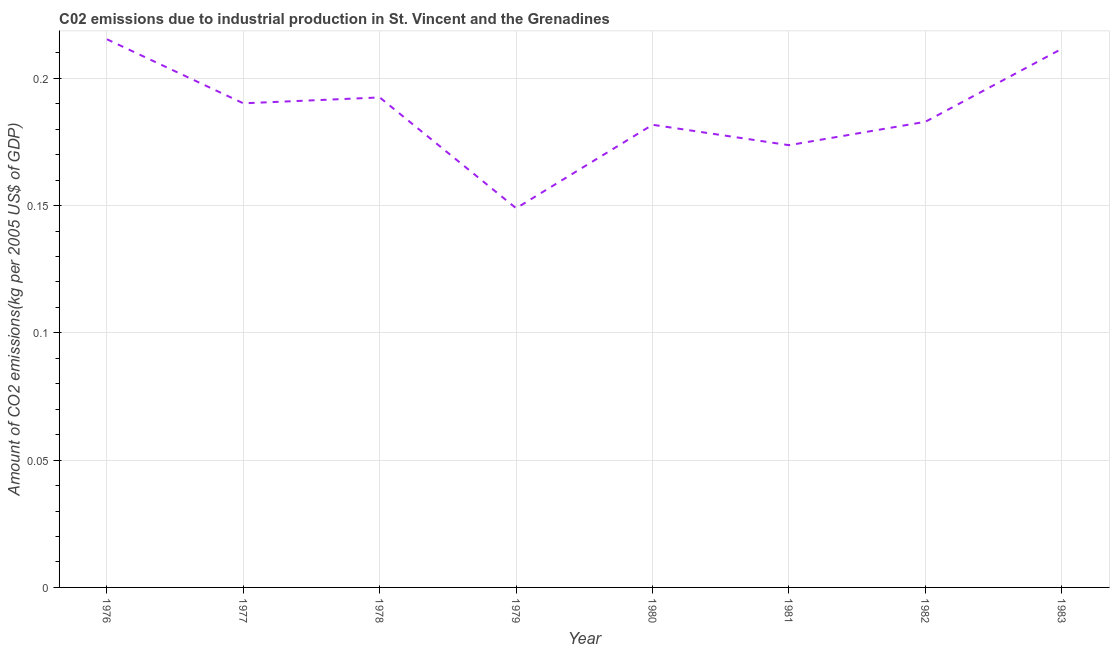What is the amount of co2 emissions in 1977?
Your answer should be compact. 0.19. Across all years, what is the maximum amount of co2 emissions?
Give a very brief answer. 0.22. Across all years, what is the minimum amount of co2 emissions?
Provide a succinct answer. 0.15. In which year was the amount of co2 emissions maximum?
Provide a succinct answer. 1976. In which year was the amount of co2 emissions minimum?
Give a very brief answer. 1979. What is the sum of the amount of co2 emissions?
Offer a terse response. 1.5. What is the difference between the amount of co2 emissions in 1982 and 1983?
Give a very brief answer. -0.03. What is the average amount of co2 emissions per year?
Your answer should be very brief. 0.19. What is the median amount of co2 emissions?
Offer a very short reply. 0.19. Do a majority of the years between 1981 and 1983 (inclusive) have amount of co2 emissions greater than 0.15000000000000002 kg per 2005 US$ of GDP?
Offer a very short reply. Yes. What is the ratio of the amount of co2 emissions in 1980 to that in 1981?
Provide a succinct answer. 1.05. Is the amount of co2 emissions in 1979 less than that in 1983?
Provide a succinct answer. Yes. What is the difference between the highest and the second highest amount of co2 emissions?
Your answer should be very brief. 0. What is the difference between the highest and the lowest amount of co2 emissions?
Ensure brevity in your answer.  0.07. In how many years, is the amount of co2 emissions greater than the average amount of co2 emissions taken over all years?
Provide a succinct answer. 4. Does the amount of co2 emissions monotonically increase over the years?
Your answer should be very brief. No. How many lines are there?
Your response must be concise. 1. How many years are there in the graph?
Give a very brief answer. 8. What is the difference between two consecutive major ticks on the Y-axis?
Your answer should be compact. 0.05. What is the title of the graph?
Give a very brief answer. C02 emissions due to industrial production in St. Vincent and the Grenadines. What is the label or title of the Y-axis?
Provide a succinct answer. Amount of CO2 emissions(kg per 2005 US$ of GDP). What is the Amount of CO2 emissions(kg per 2005 US$ of GDP) in 1976?
Provide a short and direct response. 0.22. What is the Amount of CO2 emissions(kg per 2005 US$ of GDP) of 1977?
Offer a terse response. 0.19. What is the Amount of CO2 emissions(kg per 2005 US$ of GDP) of 1978?
Your answer should be very brief. 0.19. What is the Amount of CO2 emissions(kg per 2005 US$ of GDP) of 1979?
Give a very brief answer. 0.15. What is the Amount of CO2 emissions(kg per 2005 US$ of GDP) in 1980?
Make the answer very short. 0.18. What is the Amount of CO2 emissions(kg per 2005 US$ of GDP) in 1981?
Ensure brevity in your answer.  0.17. What is the Amount of CO2 emissions(kg per 2005 US$ of GDP) in 1982?
Ensure brevity in your answer.  0.18. What is the Amount of CO2 emissions(kg per 2005 US$ of GDP) in 1983?
Provide a succinct answer. 0.21. What is the difference between the Amount of CO2 emissions(kg per 2005 US$ of GDP) in 1976 and 1977?
Your response must be concise. 0.03. What is the difference between the Amount of CO2 emissions(kg per 2005 US$ of GDP) in 1976 and 1978?
Offer a terse response. 0.02. What is the difference between the Amount of CO2 emissions(kg per 2005 US$ of GDP) in 1976 and 1979?
Provide a succinct answer. 0.07. What is the difference between the Amount of CO2 emissions(kg per 2005 US$ of GDP) in 1976 and 1980?
Your answer should be compact. 0.03. What is the difference between the Amount of CO2 emissions(kg per 2005 US$ of GDP) in 1976 and 1981?
Provide a short and direct response. 0.04. What is the difference between the Amount of CO2 emissions(kg per 2005 US$ of GDP) in 1976 and 1982?
Your response must be concise. 0.03. What is the difference between the Amount of CO2 emissions(kg per 2005 US$ of GDP) in 1976 and 1983?
Your response must be concise. 0. What is the difference between the Amount of CO2 emissions(kg per 2005 US$ of GDP) in 1977 and 1978?
Your answer should be compact. -0. What is the difference between the Amount of CO2 emissions(kg per 2005 US$ of GDP) in 1977 and 1979?
Provide a succinct answer. 0.04. What is the difference between the Amount of CO2 emissions(kg per 2005 US$ of GDP) in 1977 and 1980?
Ensure brevity in your answer.  0.01. What is the difference between the Amount of CO2 emissions(kg per 2005 US$ of GDP) in 1977 and 1981?
Provide a succinct answer. 0.02. What is the difference between the Amount of CO2 emissions(kg per 2005 US$ of GDP) in 1977 and 1982?
Offer a terse response. 0.01. What is the difference between the Amount of CO2 emissions(kg per 2005 US$ of GDP) in 1977 and 1983?
Offer a terse response. -0.02. What is the difference between the Amount of CO2 emissions(kg per 2005 US$ of GDP) in 1978 and 1979?
Keep it short and to the point. 0.04. What is the difference between the Amount of CO2 emissions(kg per 2005 US$ of GDP) in 1978 and 1980?
Your answer should be compact. 0.01. What is the difference between the Amount of CO2 emissions(kg per 2005 US$ of GDP) in 1978 and 1981?
Offer a terse response. 0.02. What is the difference between the Amount of CO2 emissions(kg per 2005 US$ of GDP) in 1978 and 1982?
Your answer should be very brief. 0.01. What is the difference between the Amount of CO2 emissions(kg per 2005 US$ of GDP) in 1978 and 1983?
Offer a very short reply. -0.02. What is the difference between the Amount of CO2 emissions(kg per 2005 US$ of GDP) in 1979 and 1980?
Your answer should be very brief. -0.03. What is the difference between the Amount of CO2 emissions(kg per 2005 US$ of GDP) in 1979 and 1981?
Make the answer very short. -0.02. What is the difference between the Amount of CO2 emissions(kg per 2005 US$ of GDP) in 1979 and 1982?
Your response must be concise. -0.03. What is the difference between the Amount of CO2 emissions(kg per 2005 US$ of GDP) in 1979 and 1983?
Give a very brief answer. -0.06. What is the difference between the Amount of CO2 emissions(kg per 2005 US$ of GDP) in 1980 and 1981?
Offer a very short reply. 0.01. What is the difference between the Amount of CO2 emissions(kg per 2005 US$ of GDP) in 1980 and 1982?
Keep it short and to the point. -0. What is the difference between the Amount of CO2 emissions(kg per 2005 US$ of GDP) in 1980 and 1983?
Provide a succinct answer. -0.03. What is the difference between the Amount of CO2 emissions(kg per 2005 US$ of GDP) in 1981 and 1982?
Offer a terse response. -0.01. What is the difference between the Amount of CO2 emissions(kg per 2005 US$ of GDP) in 1981 and 1983?
Make the answer very short. -0.04. What is the difference between the Amount of CO2 emissions(kg per 2005 US$ of GDP) in 1982 and 1983?
Give a very brief answer. -0.03. What is the ratio of the Amount of CO2 emissions(kg per 2005 US$ of GDP) in 1976 to that in 1977?
Your answer should be very brief. 1.13. What is the ratio of the Amount of CO2 emissions(kg per 2005 US$ of GDP) in 1976 to that in 1978?
Give a very brief answer. 1.12. What is the ratio of the Amount of CO2 emissions(kg per 2005 US$ of GDP) in 1976 to that in 1979?
Offer a terse response. 1.45. What is the ratio of the Amount of CO2 emissions(kg per 2005 US$ of GDP) in 1976 to that in 1980?
Keep it short and to the point. 1.19. What is the ratio of the Amount of CO2 emissions(kg per 2005 US$ of GDP) in 1976 to that in 1981?
Provide a succinct answer. 1.24. What is the ratio of the Amount of CO2 emissions(kg per 2005 US$ of GDP) in 1976 to that in 1982?
Ensure brevity in your answer.  1.18. What is the ratio of the Amount of CO2 emissions(kg per 2005 US$ of GDP) in 1976 to that in 1983?
Give a very brief answer. 1.02. What is the ratio of the Amount of CO2 emissions(kg per 2005 US$ of GDP) in 1977 to that in 1978?
Keep it short and to the point. 0.99. What is the ratio of the Amount of CO2 emissions(kg per 2005 US$ of GDP) in 1977 to that in 1979?
Keep it short and to the point. 1.28. What is the ratio of the Amount of CO2 emissions(kg per 2005 US$ of GDP) in 1977 to that in 1980?
Your answer should be compact. 1.05. What is the ratio of the Amount of CO2 emissions(kg per 2005 US$ of GDP) in 1977 to that in 1981?
Offer a very short reply. 1.09. What is the ratio of the Amount of CO2 emissions(kg per 2005 US$ of GDP) in 1977 to that in 1982?
Make the answer very short. 1.04. What is the ratio of the Amount of CO2 emissions(kg per 2005 US$ of GDP) in 1977 to that in 1983?
Provide a succinct answer. 0.9. What is the ratio of the Amount of CO2 emissions(kg per 2005 US$ of GDP) in 1978 to that in 1979?
Keep it short and to the point. 1.29. What is the ratio of the Amount of CO2 emissions(kg per 2005 US$ of GDP) in 1978 to that in 1980?
Make the answer very short. 1.06. What is the ratio of the Amount of CO2 emissions(kg per 2005 US$ of GDP) in 1978 to that in 1981?
Your answer should be compact. 1.11. What is the ratio of the Amount of CO2 emissions(kg per 2005 US$ of GDP) in 1978 to that in 1982?
Your response must be concise. 1.05. What is the ratio of the Amount of CO2 emissions(kg per 2005 US$ of GDP) in 1978 to that in 1983?
Make the answer very short. 0.91. What is the ratio of the Amount of CO2 emissions(kg per 2005 US$ of GDP) in 1979 to that in 1980?
Your response must be concise. 0.82. What is the ratio of the Amount of CO2 emissions(kg per 2005 US$ of GDP) in 1979 to that in 1981?
Keep it short and to the point. 0.86. What is the ratio of the Amount of CO2 emissions(kg per 2005 US$ of GDP) in 1979 to that in 1982?
Your response must be concise. 0.81. What is the ratio of the Amount of CO2 emissions(kg per 2005 US$ of GDP) in 1979 to that in 1983?
Offer a terse response. 0.7. What is the ratio of the Amount of CO2 emissions(kg per 2005 US$ of GDP) in 1980 to that in 1981?
Make the answer very short. 1.05. What is the ratio of the Amount of CO2 emissions(kg per 2005 US$ of GDP) in 1980 to that in 1983?
Offer a terse response. 0.86. What is the ratio of the Amount of CO2 emissions(kg per 2005 US$ of GDP) in 1981 to that in 1983?
Provide a short and direct response. 0.82. What is the ratio of the Amount of CO2 emissions(kg per 2005 US$ of GDP) in 1982 to that in 1983?
Ensure brevity in your answer.  0.86. 